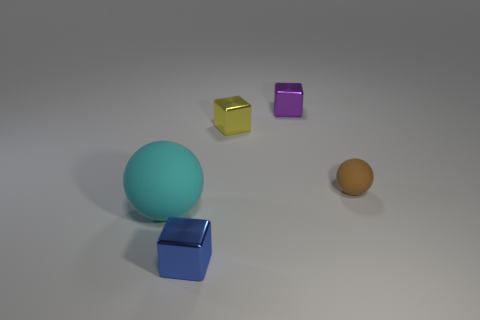Add 2 yellow matte cylinders. How many objects exist? 7 Subtract all cubes. How many objects are left? 2 Subtract all small cyan matte cylinders. Subtract all large cyan objects. How many objects are left? 4 Add 4 brown things. How many brown things are left? 5 Add 5 cyan matte balls. How many cyan matte balls exist? 6 Subtract 0 purple cylinders. How many objects are left? 5 